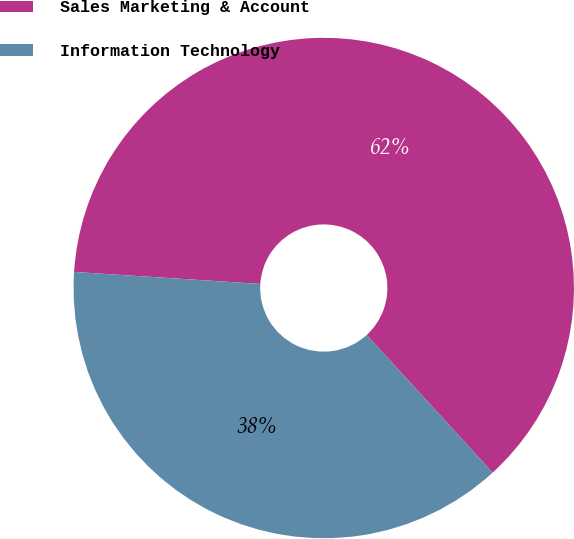Convert chart to OTSL. <chart><loc_0><loc_0><loc_500><loc_500><pie_chart><fcel>Sales Marketing & Account<fcel>Information Technology<nl><fcel>62.18%<fcel>37.82%<nl></chart> 